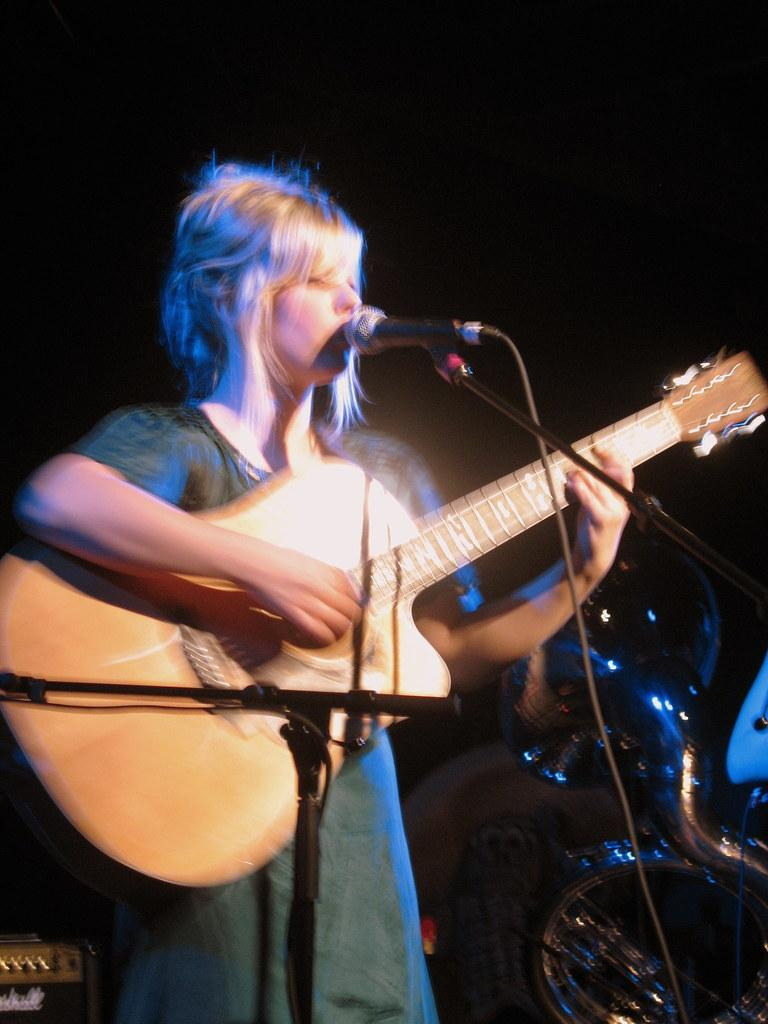Who is the main subject in the image? There is a lady in the image. What is the lady doing in the image? The lady is playing a guitar. What object is in front of the lady? There is a microphone in front of the lady. How would you describe the background of the image? The background of the image is dark. How does the lady's servant help her during the performance in the image? There is no servant present in the image, and therefore no such assistance can be observed. 